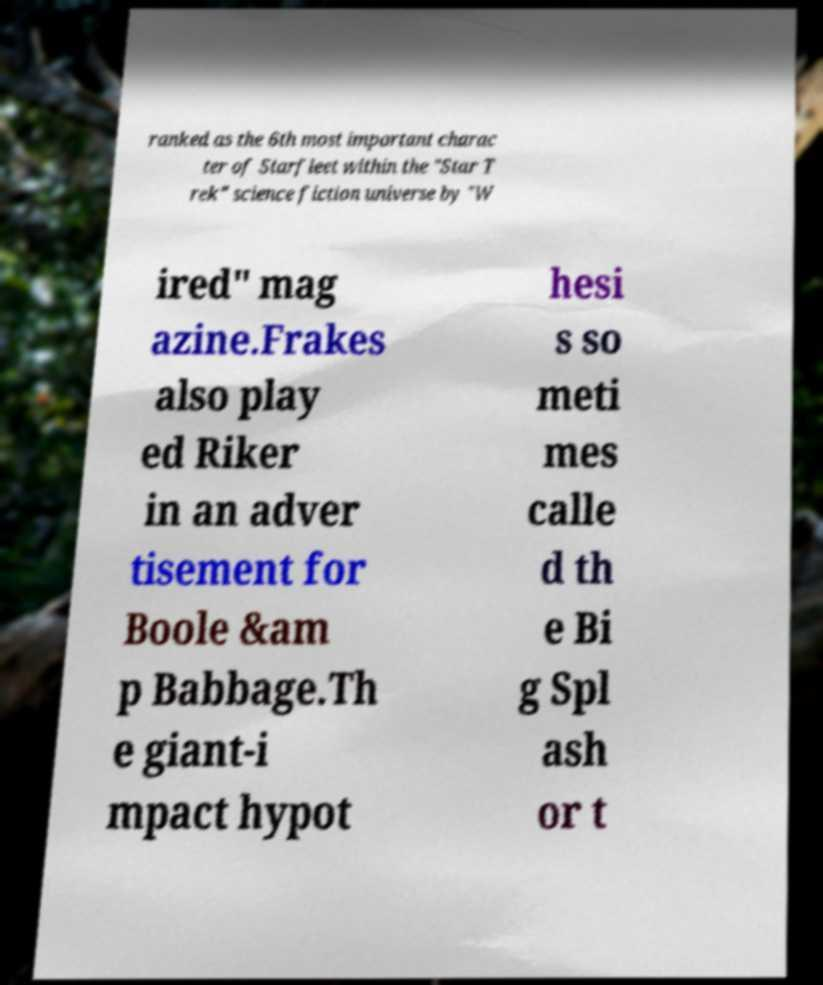There's text embedded in this image that I need extracted. Can you transcribe it verbatim? ranked as the 6th most important charac ter of Starfleet within the "Star T rek" science fiction universe by "W ired" mag azine.Frakes also play ed Riker in an adver tisement for Boole &am p Babbage.Th e giant-i mpact hypot hesi s so meti mes calle d th e Bi g Spl ash or t 